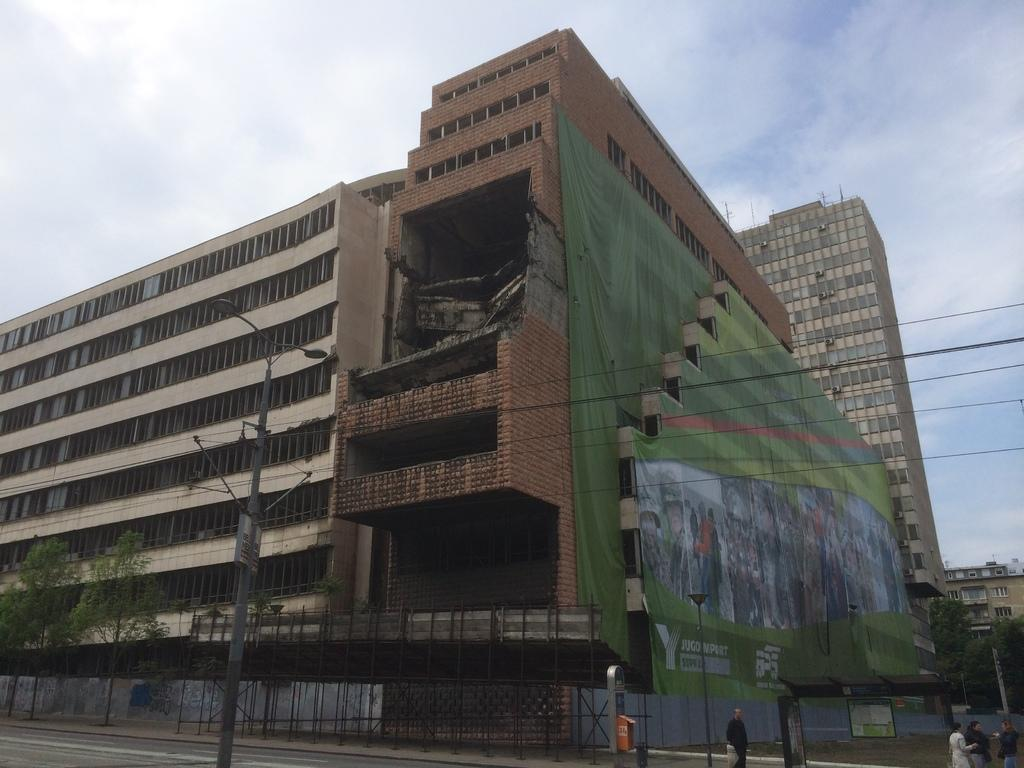What type of construction is taking place in the image? There are buildings under construction in the image. What infrastructure elements can be seen in the image? Electric poles and street lights are visible in the image. What type of vegetation is present in the image? Trees are in the image. What are the people in the image doing? There are persons on the road in the image. What type of mail service facility is visible in the image? A post box is visible in the image. What is visible in the sky in the image? The sky is visible in the image, and clouds are present in the sky. How many questions are being asked in the image? There is no indication of any questions being asked in the image; it depicts a scene with buildings under construction, electric poles, street lights, trees, persons on the road, a post box, and a sky with clouds. What is the amount of water visible in the image? There is no visible water present in the image; it features buildings under construction, electric poles, street lights, trees, persons on the road, a post box, and a sky with clouds. 